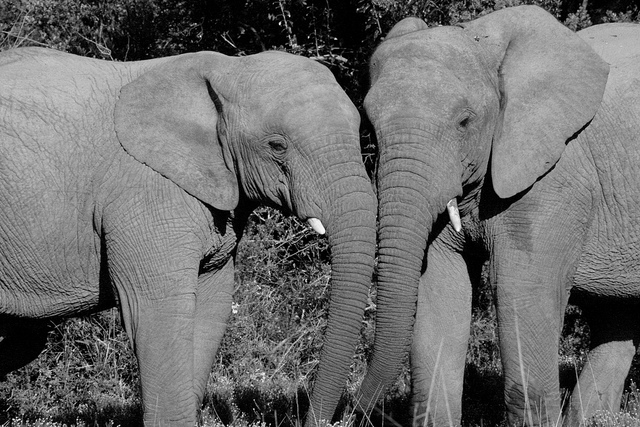<image>What kind of filter is used? I'm not sure what kind of filter is used. It could possibly be a black and white filter. What kind of filter is used? The filter used is black and white. 